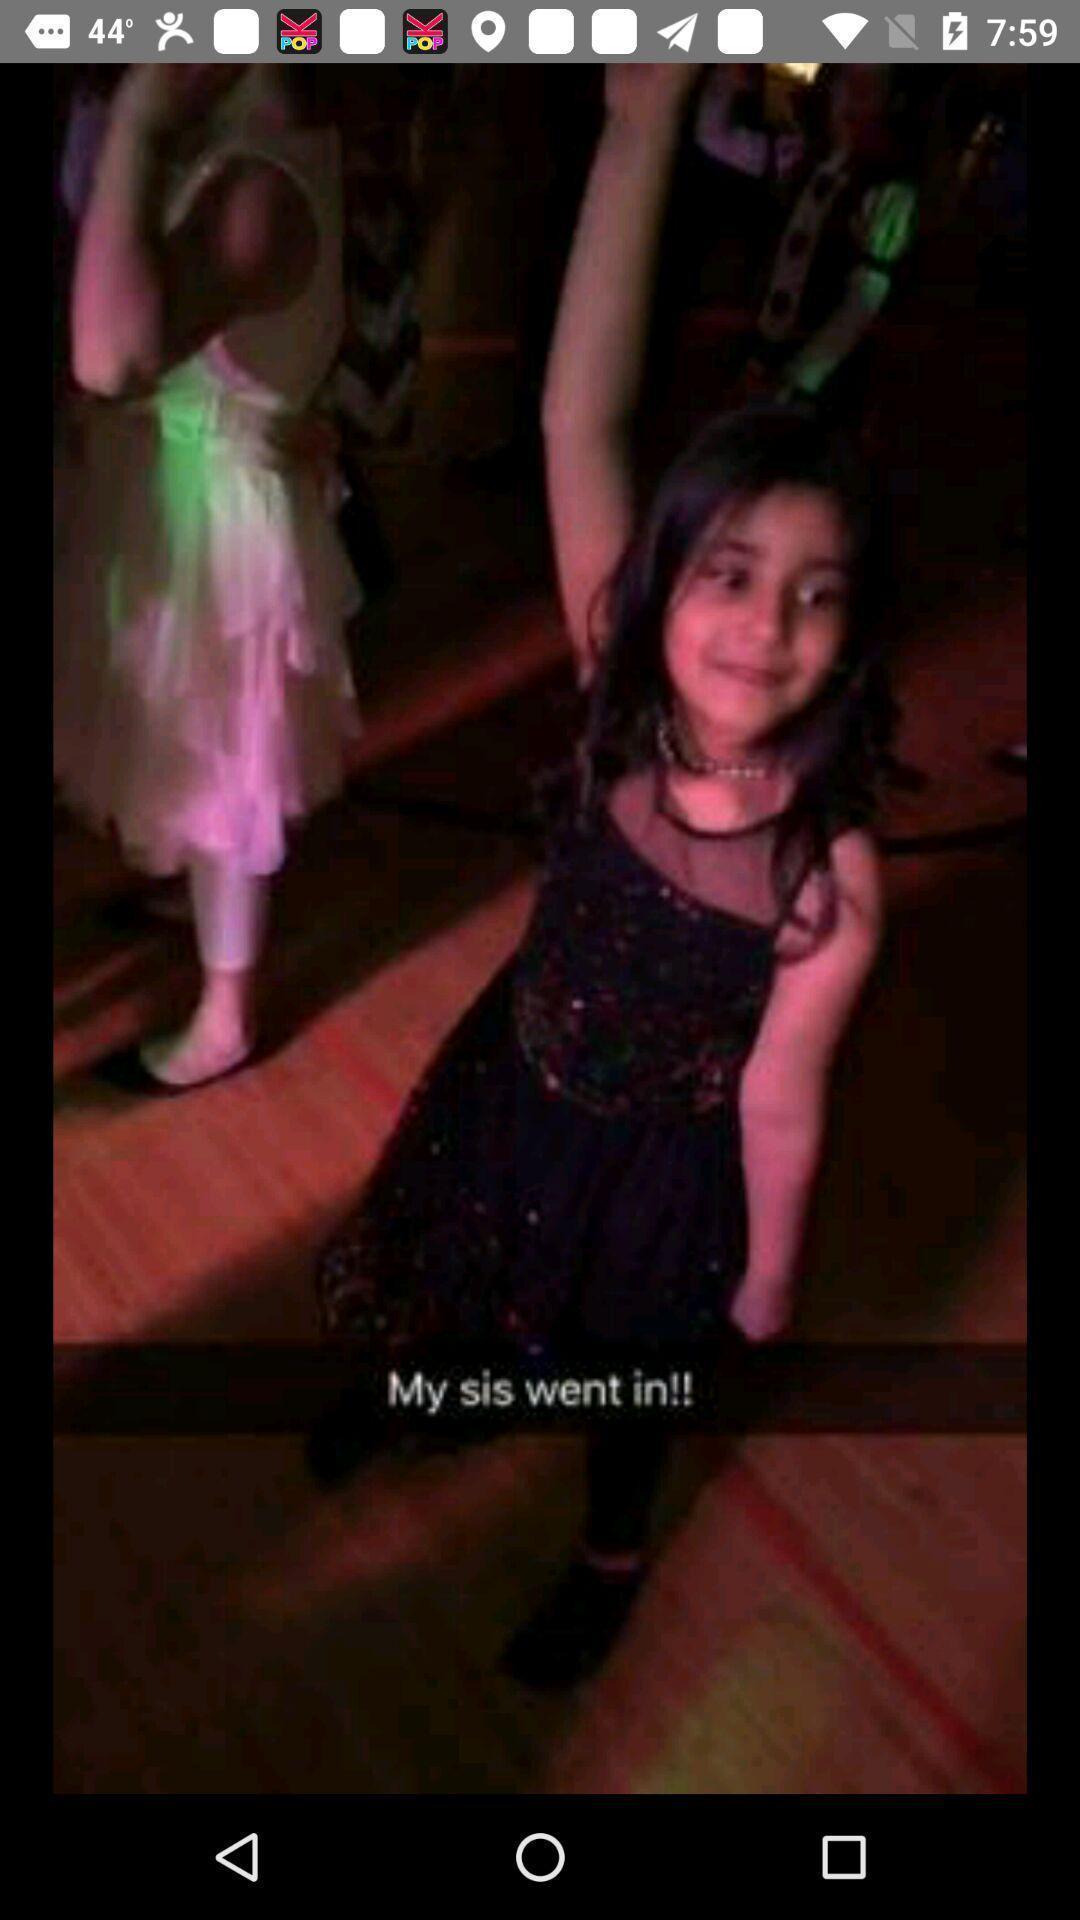Tell me what you see in this picture. Screen displaying an image in a mobile application. 